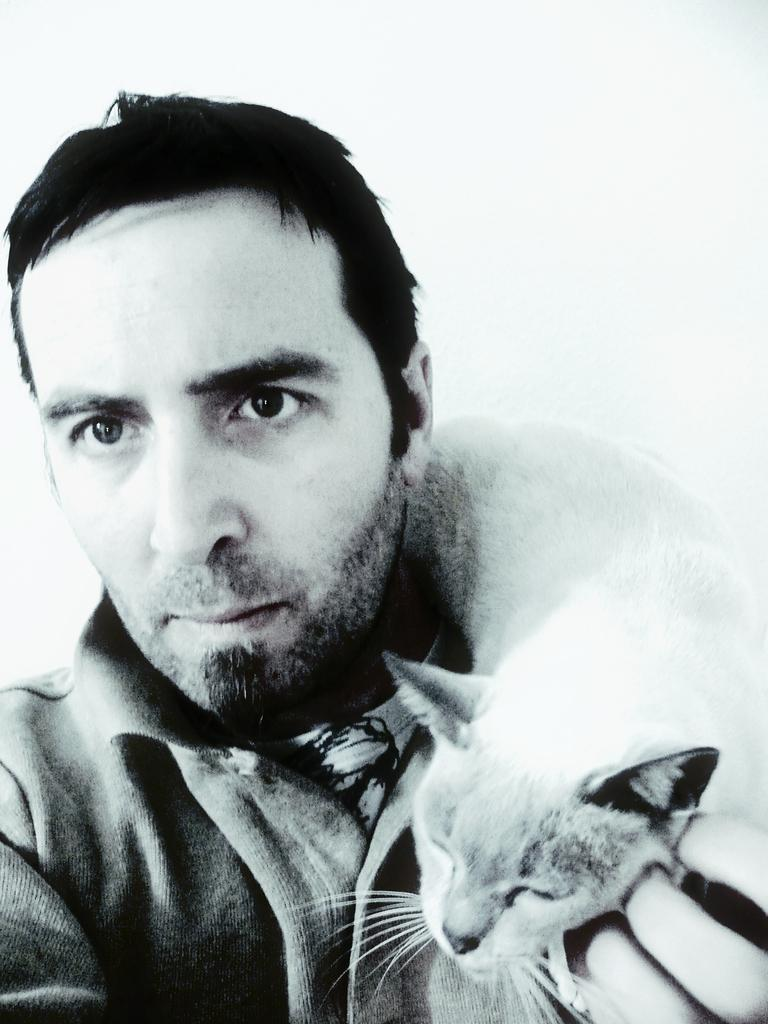Who is present in the image? There is a man in the image. What is the man wearing? The man is wearing a coat. What is the man holding in the image? The man is holding a cat on his shoulder. What type of songs is the man composing on his quill in the image? There is no quill or indication of song composition in the image; the man is simply holding a cat on his shoulder. 